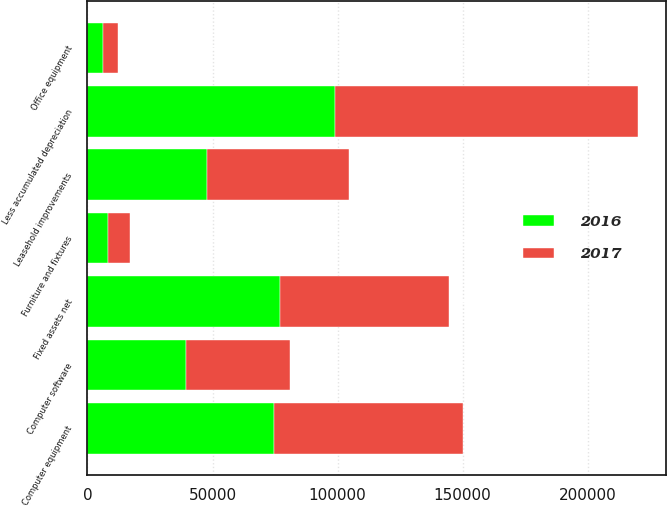Convert chart to OTSL. <chart><loc_0><loc_0><loc_500><loc_500><stacked_bar_chart><ecel><fcel>Computer equipment<fcel>Computer software<fcel>Leasehold improvements<fcel>Office equipment<fcel>Furniture and fixtures<fcel>Less accumulated depreciation<fcel>Fixed assets net<nl><fcel>2017<fcel>75281<fcel>41527<fcel>56758<fcel>5843<fcel>9108<fcel>121217<fcel>67300<nl><fcel>2016<fcel>74684<fcel>39277<fcel>47773<fcel>6344<fcel>8051<fcel>99002<fcel>77127<nl></chart> 